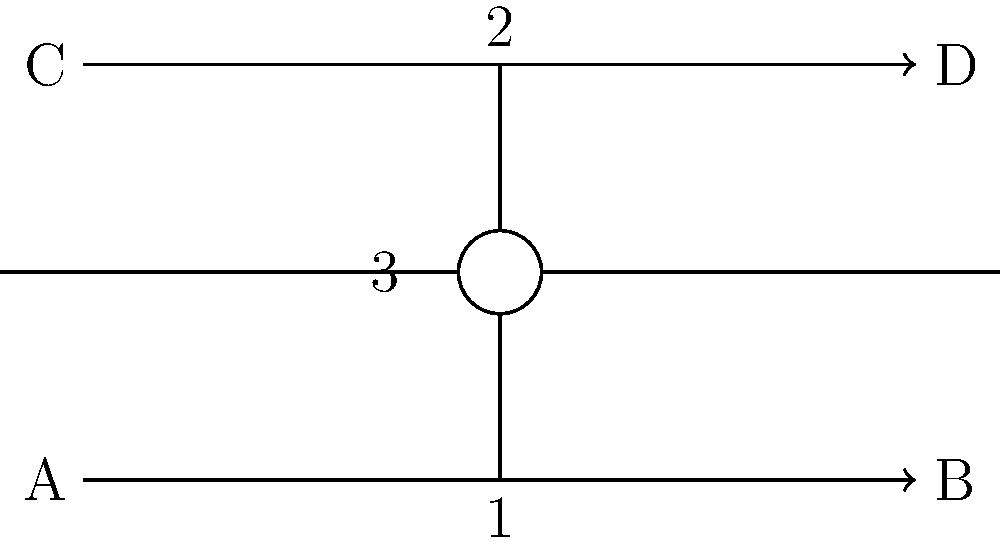In the circuit diagram above, which musical metaphor could be used to describe the relationship between components 1, 2, and 3 if they represent a resistor, capacitor, and switch, respectively? How might this arrangement remind you of a band's dynamics during a live performance? To answer this question, let's break down the components and their roles in the circuit, then draw a musical analogy:

1. Component 1 (bottom) is a resistor, represented by a rectangular symbol. In a circuit, a resistor controls the flow of current, much like a rhythm guitarist controls the tempo and provides a steady foundation for a song.

2. Component 2 (top) is a capacitor, shown by two parallel lines. Capacitors store and release electrical energy, similar to how a lead singer builds up energy and releases it in powerful vocal phrases during a performance.

3. Component 3 (middle) is a switch, depicted by an open circle. Switches control the on/off state of a circuit, much like how a drummer's cymbal crashes or sudden stops can dramatically change the energy of a song.

The arrangement of these components in parallel creates a circuit where each element can influence the overall behavior, yet they maintain some independence. This is reminiscent of how different band members in a live performance contribute their unique parts while still working together harmoniously.

The resistor (rhythm guitar) provides a constant, steady presence. The capacitor (lead singer) can build up and release energy, adding dynamics to the performance. The switch (drummer) can dramatically alter the circuit's state, much like how a drummer's accents and breaks can change the feel of a song instantly.

This parallel arrangement allows for a rich, layered sound in music, where each element can shine individually but also blend seamlessly, creating a full, dynamic performance – much like how these components interact to create a functioning circuit with various possible behaviors depending on the switch state and the interplay between the resistor and capacitor.
Answer: Rhythm section analogy: Resistor as rhythm guitar, capacitor as lead singer, switch as drummer, working in parallel for a dynamic performance. 